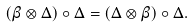<formula> <loc_0><loc_0><loc_500><loc_500>\left ( \beta \otimes \Delta \right ) \circ \Delta = \left ( \Delta \otimes \beta \right ) \circ \Delta .</formula> 